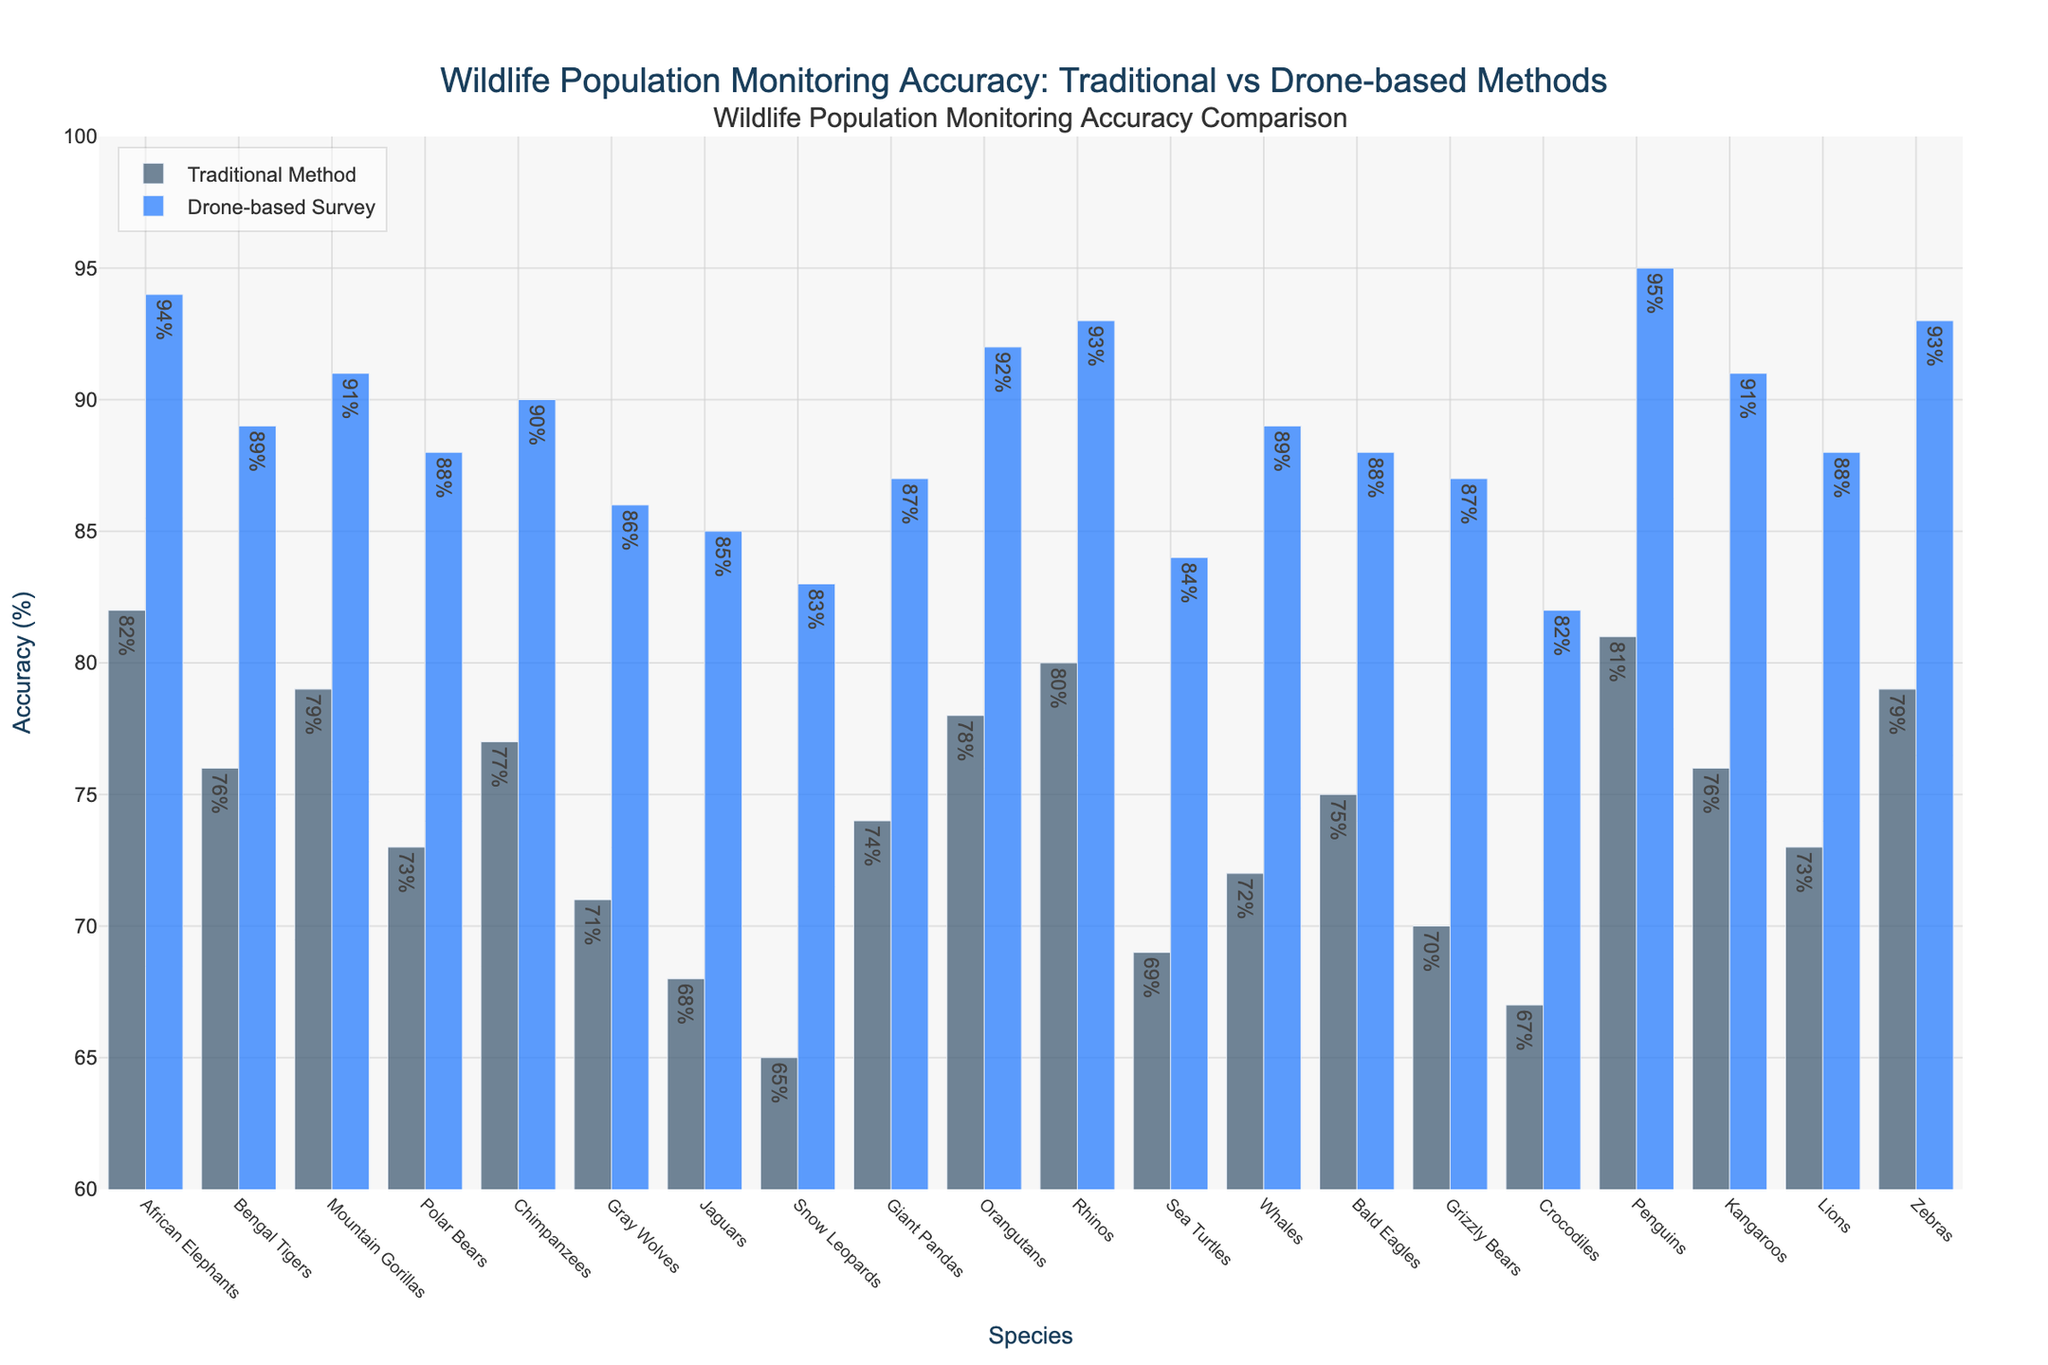Which species has the highest monitoring accuracy using the drone-based survey method? Penguins have the highest monitoring accuracy using the drone-based survey method with an accuracy of 95%. This is determined by visually identifying the tallest bar associated with the drone-based survey method.
Answer: Penguins Which method provides generally higher accuracy across all species, traditional or drone-based? By comparing the height of the bars for each species, it is evident that for all species, the drone-based survey method has higher accuracy than the traditional method. This is consistent across all species shown on the plot.
Answer: Drone-based What is the accuracy difference between the traditional method and drone-based surveys for African Elephants? The traditional method accuracy is 82% and the drone-based survey accuracy is 94%. The difference is calculated as 94% - 82% = 12%.
Answer: 12% Which species show less than 85% accuracy in the traditional method but have at least 90% accuracy in the drone-based survey? Identify species with a traditional accuracy less than 85%: Crocodiles, Snow Leopards, Sea Turtles, Gray Wolves, Jaguars. Among these, Jaguars, Gray Wolves, and Snow Leopards have at least 90% accuracy in the drone-based survey.
Answer: Jaguars, Gray Wolves, Snow Leopards How many species have both methods achieving over 80% accuracy? Count the species where both bars are higher than 80%. The species that satisfy this condition are African Elephants, Mountain Gorillas, Orangutans, Rhinos, Zebras, and Penguins. So, total 6 species.
Answer: 6 What is the average drone-based survey accuracy across all species? Sum all drone-based survey accuracies and divide by the number of species: (94 + 89 + 91 + 88 + 90 + 86 + 85 + 83 + 87 + 92 + 93 + 84 + 89 + 88 + 87 + 82 + 95 + 91 + 88 + 93) / 20. This equals 1804 / 20 = 90.2%.
Answer: 90.2% Which species shows the smallest difference in accuracy between the traditional method and drone-based survey? Calculate the difference for each species and find the smallest: African Elephants (12), Bengal Tigers (13), Mountain Gorillas (12), Polar Bears (15), Chimpanzees (13), Gray Wolves (15), Jaguars (17), Snow Leopards (18), Giant Pandas (13), Orangutans (14), Rhinos (13), Sea Turtles (15), Whales (17), Bald Eagles (13), Grizzly Bears (17), Crocodiles (15), Penguins (14), Kangaroos (15), Lions (15), Zebras (14). The smallest difference belongs to Mountain Gorillas and African Elephants (which both have a difference of 12).
Answer: African Elephants, Mountain Gorillas Which species have equal accuracy for traditional and drone-based methods for population monitoring? There are no bars where the traditional and drone-based method accuracies are equal when visually comparing all species.
Answer: None 